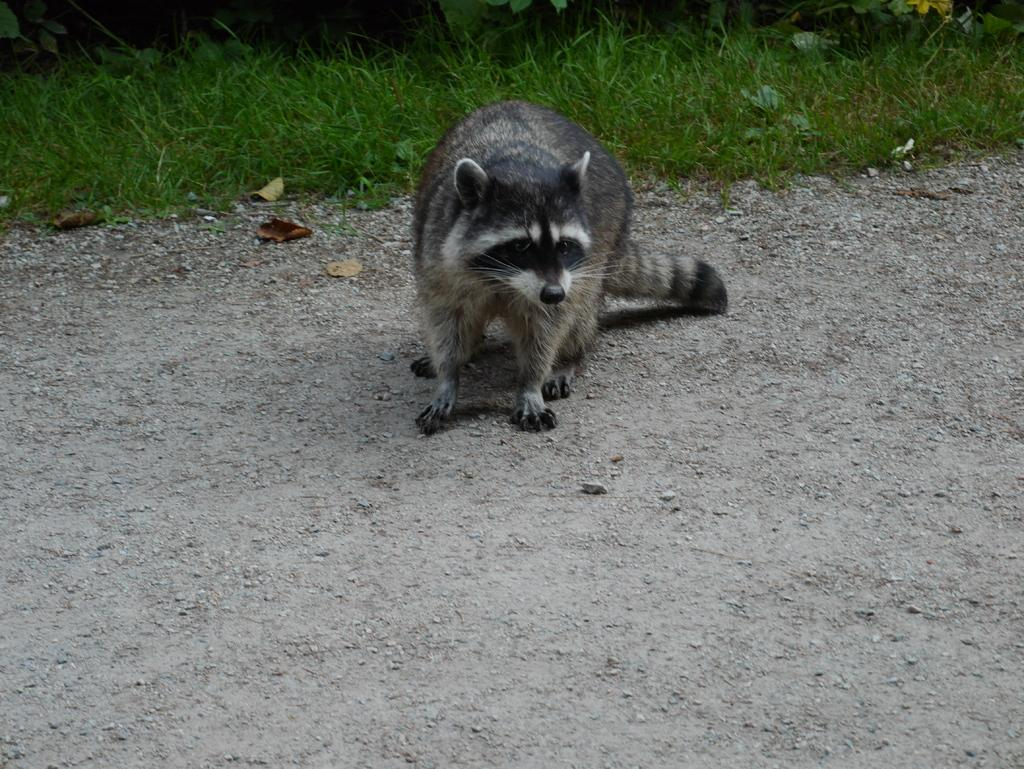What type of animal can be seen on the ground in the image? There is an animal on the ground in the image. What can be seen at the top of the image? There are plants visible at the top of the image. What type of vegetation is present in the image? Grass is present in the image. What is the distribution of sheep in the image? There are no sheep present in the image, so their distribution cannot be determined. 